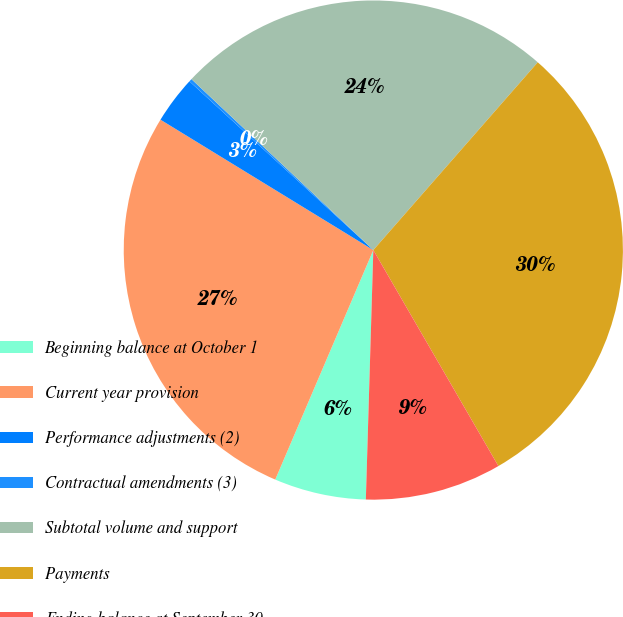Convert chart. <chart><loc_0><loc_0><loc_500><loc_500><pie_chart><fcel>Beginning balance at October 1<fcel>Current year provision<fcel>Performance adjustments (2)<fcel>Contractual amendments (3)<fcel>Subtotal volume and support<fcel>Payments<fcel>Ending balance at September 30<nl><fcel>5.95%<fcel>27.32%<fcel>3.07%<fcel>0.19%<fcel>24.44%<fcel>30.2%<fcel>8.83%<nl></chart> 